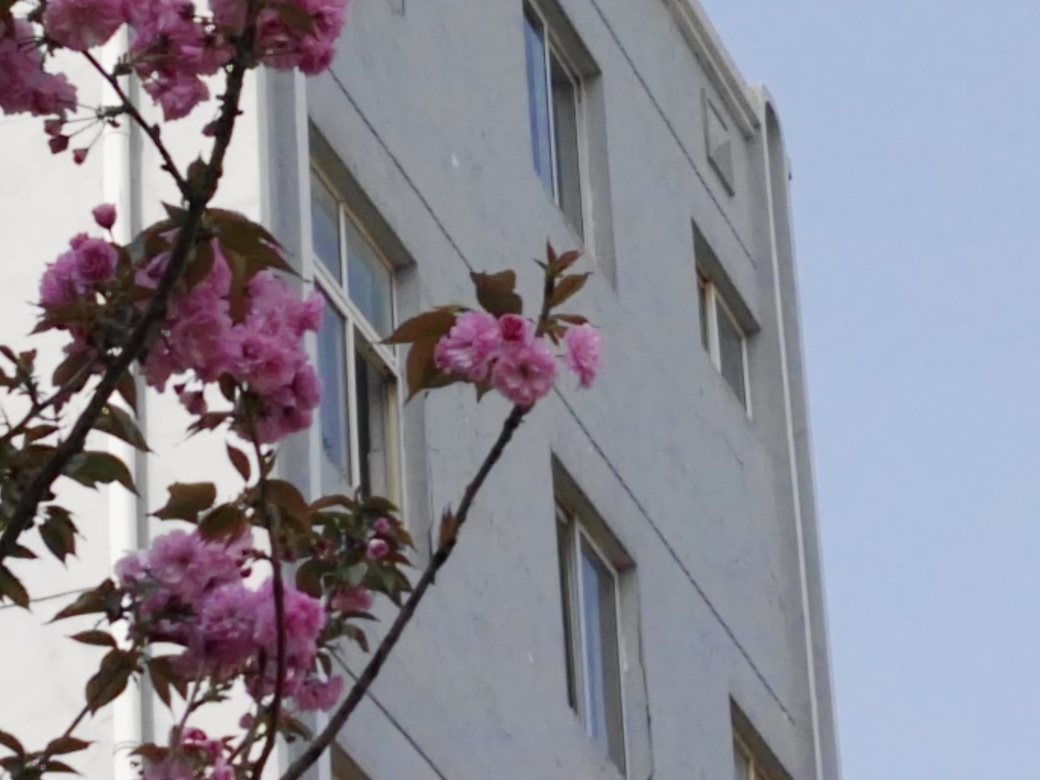What is the quality of this image? The quality of the image is suboptimal. The focus appears to be on the blooming pink flowers in the foreground, but both the flowers and the building in the background appear slightly blurry, which suggests camera shake or a low-resolution capture. The lighting is flat, likely due to an overcast sky, which does not lend much contrast or depth to the subjects. However, the composition can be appreciated for attempting to capture a natural element in an urban setting. 